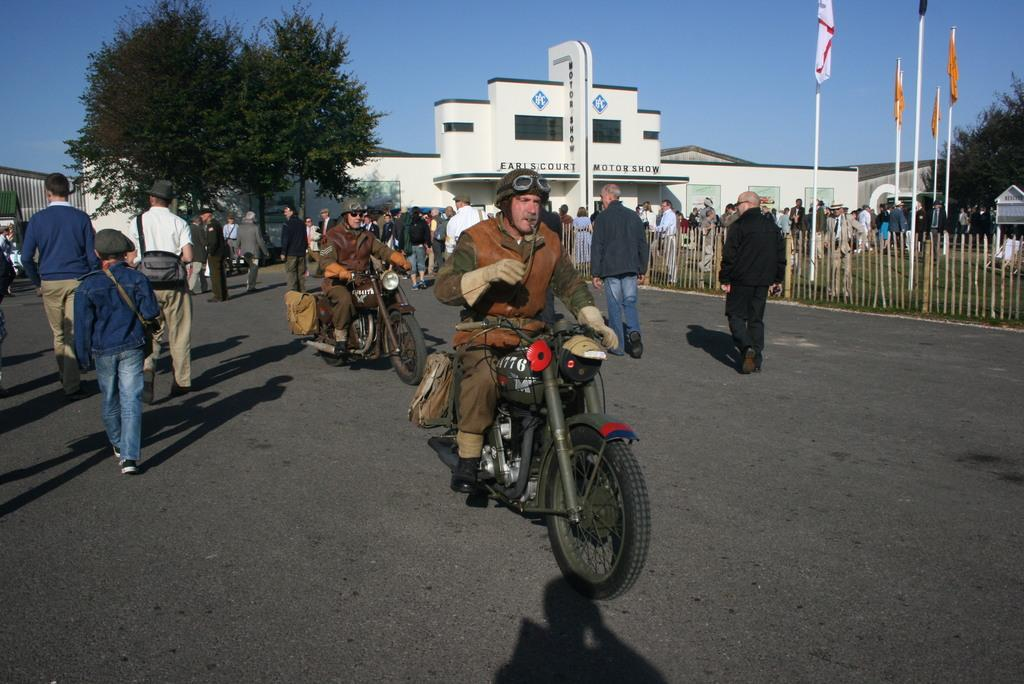How many people are riding the motorbike in the image? There are two persons riding a motorbike in the image. What are the other people in the image doing? There is a group of people walking in the image. What can be seen on the poles in the image? There are flags on poles in the image. What is visible in the background of the image? There is a building and a tree in the background of the image. What type of beetle can be seen crawling on the motorbike in the image? There is no beetle present on the motorbike in the image. What type of legal advice can be sought from the lawyer in the image? There is no lawyer present in the image. 